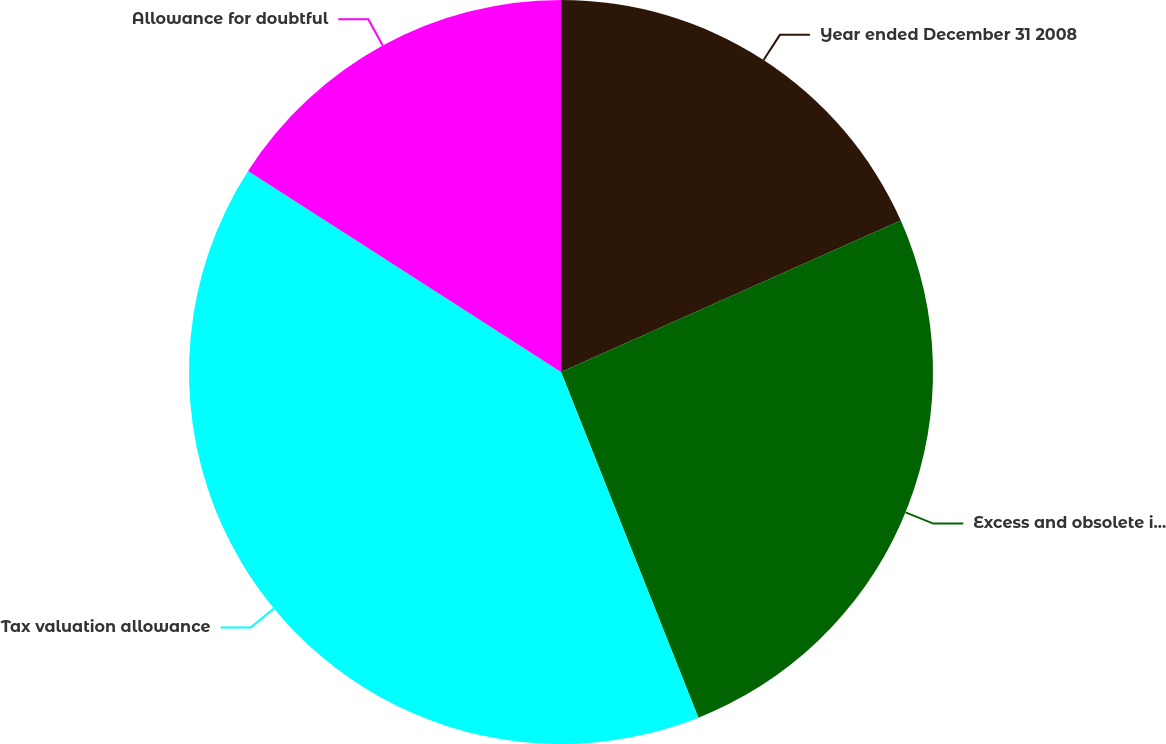Convert chart. <chart><loc_0><loc_0><loc_500><loc_500><pie_chart><fcel>Year ended December 31 2008<fcel>Excess and obsolete inventory<fcel>Tax valuation allowance<fcel>Allowance for doubtful<nl><fcel>18.33%<fcel>25.65%<fcel>40.11%<fcel>15.91%<nl></chart> 